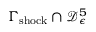<formula> <loc_0><loc_0><loc_500><loc_500>\Gamma _ { s h o c k } \cap \mathcal { D } _ { \epsilon } ^ { 5 }</formula> 